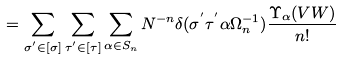<formula> <loc_0><loc_0><loc_500><loc_500>= \sum _ { \sigma ^ { ^ { \prime } } \in [ \sigma ] } \sum _ { \tau ^ { ^ { \prime } } \in [ \tau ] } \sum _ { \alpha \in S _ { n } } N ^ { - n } \delta ( \sigma ^ { ^ { \prime } } \tau ^ { ^ { \prime } } \alpha \Omega _ { n } ^ { - 1 } ) \frac { \Upsilon _ { \alpha } ( V W ) } { n ! }</formula> 